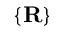Convert formula to latex. <formula><loc_0><loc_0><loc_500><loc_500>\{ R \}</formula> 